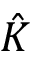<formula> <loc_0><loc_0><loc_500><loc_500>\hat { K }</formula> 